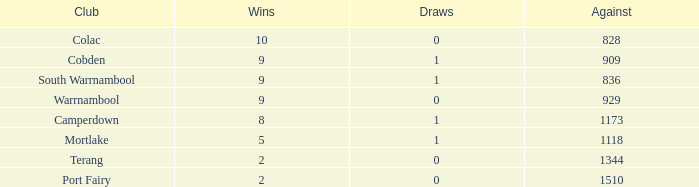For clubs with more than 2 wins, 5 losses, and 0 draws, what is the aggregate of against values? 0.0. 